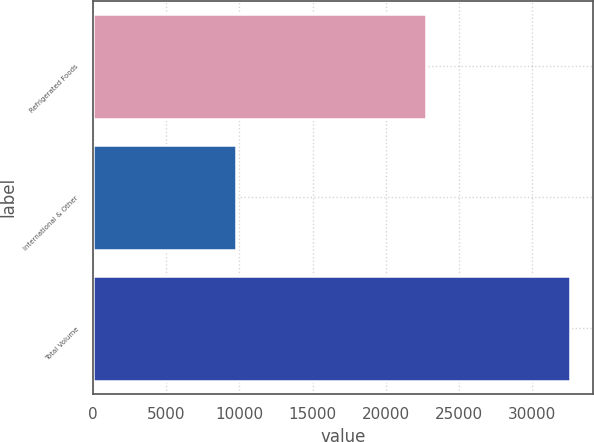Convert chart. <chart><loc_0><loc_0><loc_500><loc_500><bar_chart><fcel>Refrigerated Foods<fcel>International & Other<fcel>Total Volume<nl><fcel>22757<fcel>9807<fcel>32564<nl></chart> 